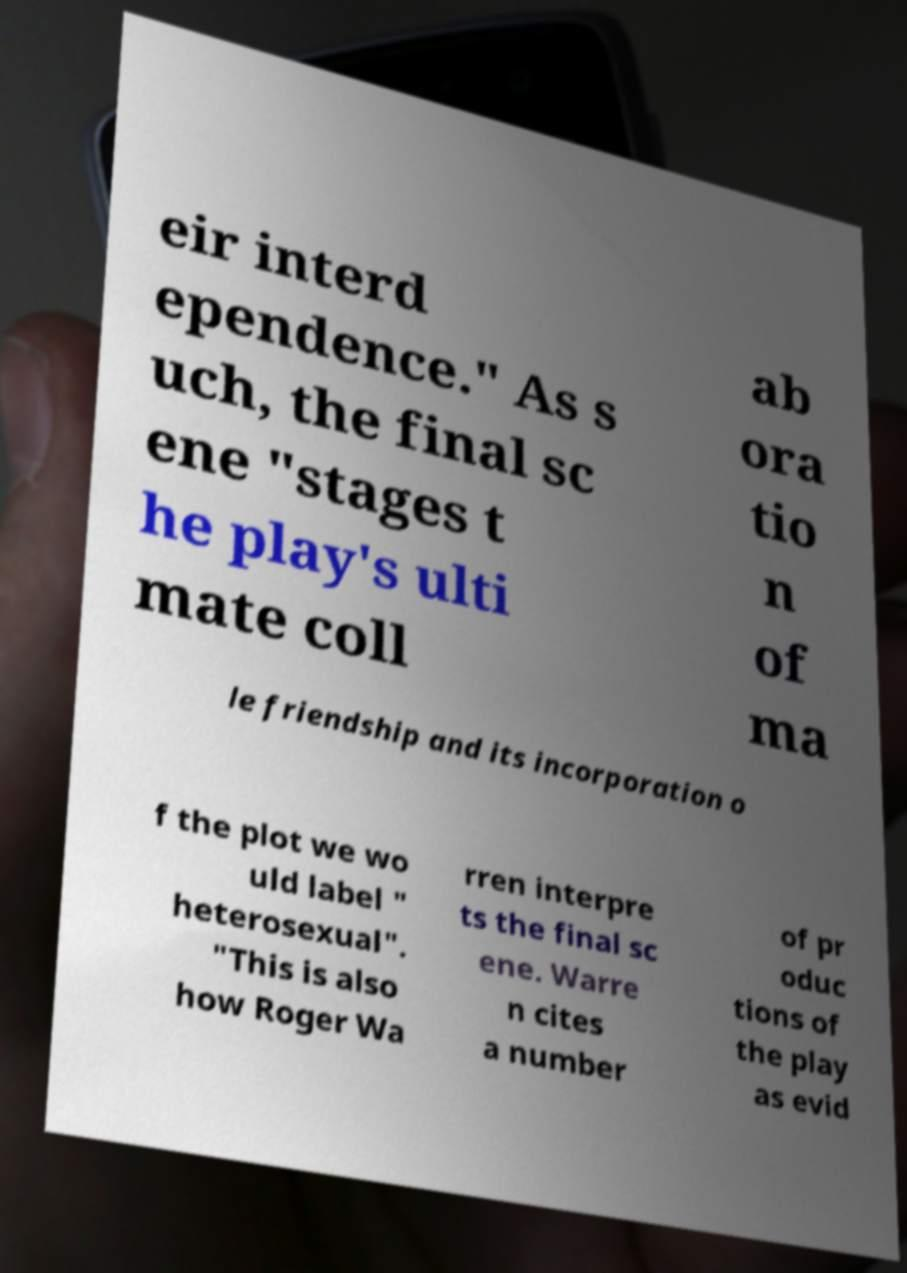For documentation purposes, I need the text within this image transcribed. Could you provide that? eir interd ependence." As s uch, the final sc ene "stages t he play's ulti mate coll ab ora tio n of ma le friendship and its incorporation o f the plot we wo uld label " heterosexual". "This is also how Roger Wa rren interpre ts the final sc ene. Warre n cites a number of pr oduc tions of the play as evid 